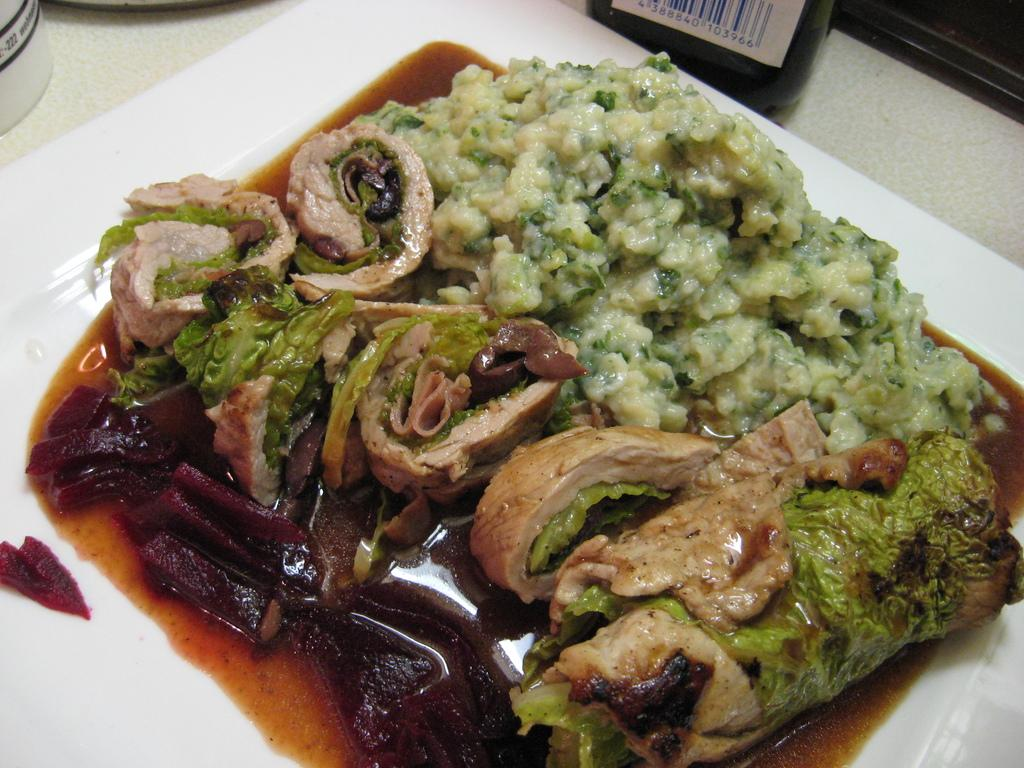What type of furniture is present in the image? There is a table in the image. What is on the table? There is a plate containing food on the table. Are there any other objects on the table? Yes, there are objects placed on the table. Can you see any tickets on the table in the image? There is no mention of tickets in the image, so we cannot determine if any are present. 